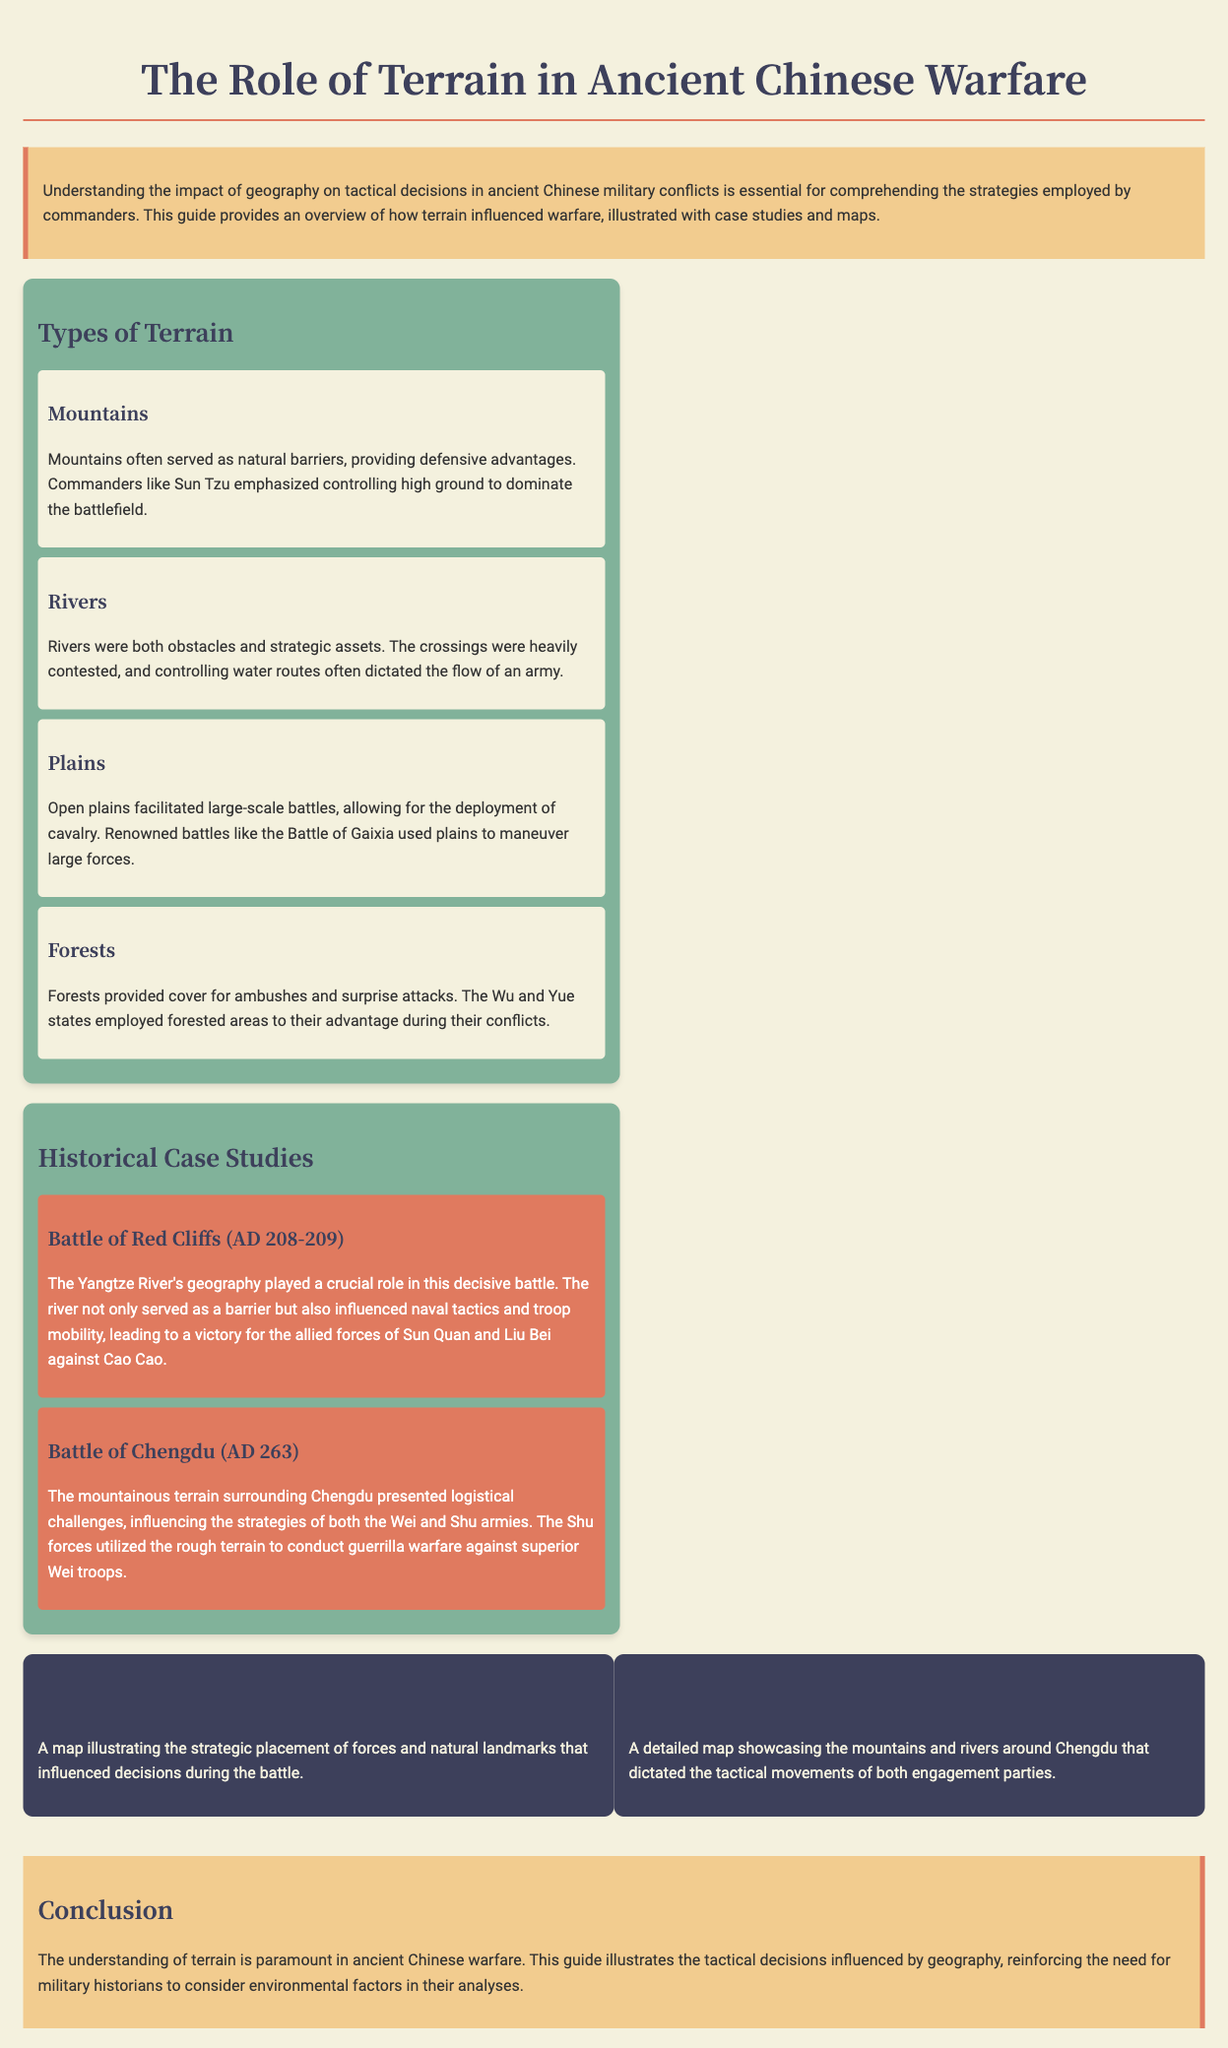What is the title of the manual? The title of the manual is indicated at the top of the document, signaling its focus on ancient Chinese warfare.
Answer: The Role of Terrain in Ancient Chinese Warfare What type of terrain is emphasized for defensive advantages? The document highlights certain terrain types that provide strategic benefits, including mountains.
Answer: Mountains What river influenced the Battle of Red Cliffs? The document specifies that one significant geographical feature played a crucial role in this battle, which is named.
Answer: Yangtze River How many historical case studies are presented? The document lists the number of case studies related to the operations discussed in ancient Chinese warfare.
Answer: Two Who were the allied forces in the Battle of Red Cliffs? The document mentions the key leaders of the combined forces that defeated Cao Cao in this battle.
Answer: Sun Quan and Liu Bei What does controlling rivers often dictate? The document explains the strategic importance of rivers to military tactics, specifically regarding movement and positioning.
Answer: Flow of an army What was the nature of the terrain around Chengdu? The manual discusses the influence of geographical features on military strategy, particularly in combat scenarios.
Answer: Mountainous Which state utilized forested areas for ambushes? The historical context provided in the document details how specific regions were exploited for tactical advantages during conflicts.
Answer: Wu and Yue What is highlighted as paramount in ancient Chinese warfare? The conclusion emphasizes a critical aspect for understanding military history in ancient China.
Answer: Understanding of terrain 